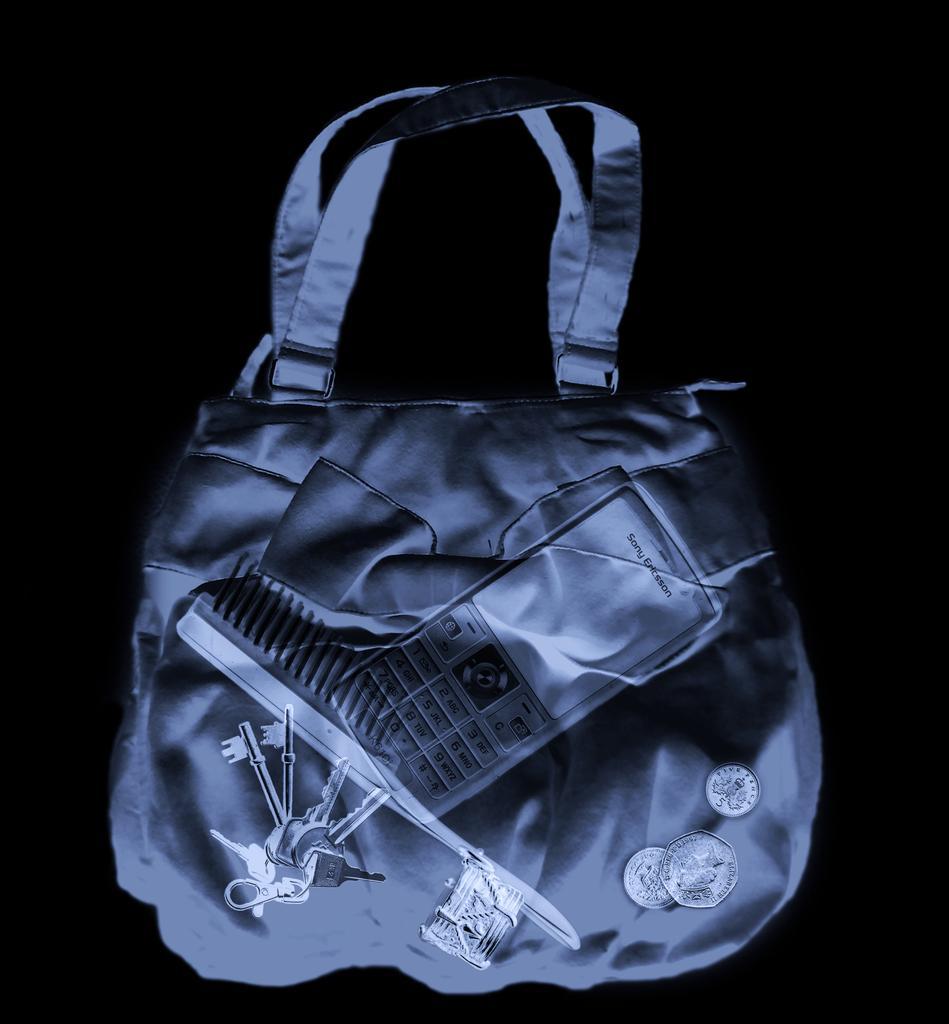In one or two sentences, can you explain what this image depicts? Here we can see a hand bag and in that we can see a mobile phone, comb and keys, coins present 